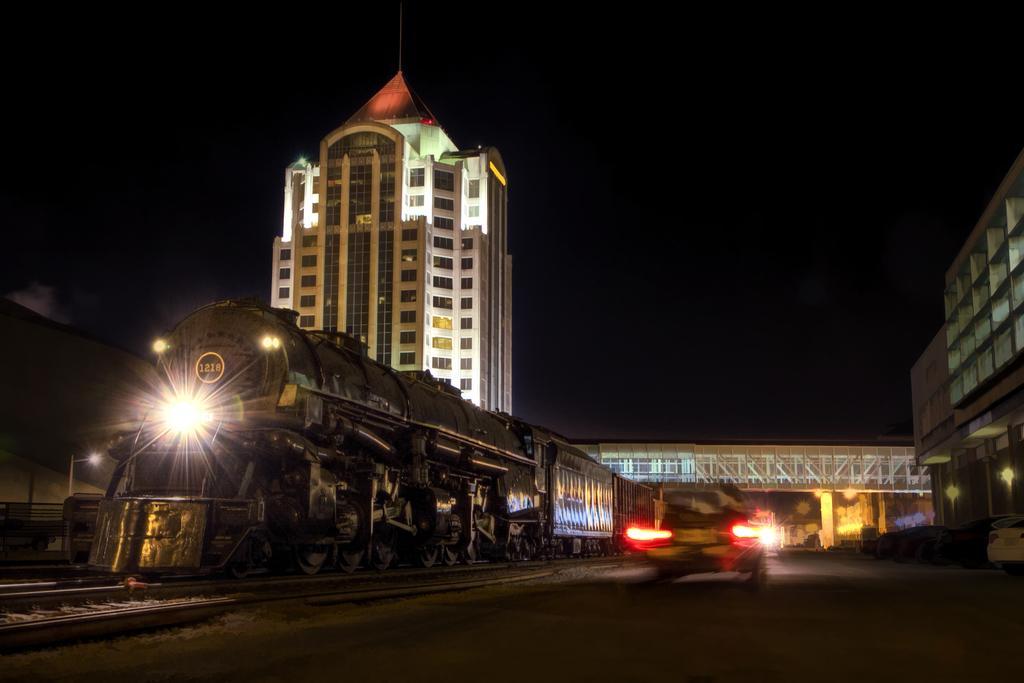Describe this image in one or two sentences. In the middle of the image we can see some vehicles on the road. Behind the vehicles there are some buildings and bridge. In the bottom left corner of the image we can see some tracks and locomotive. 